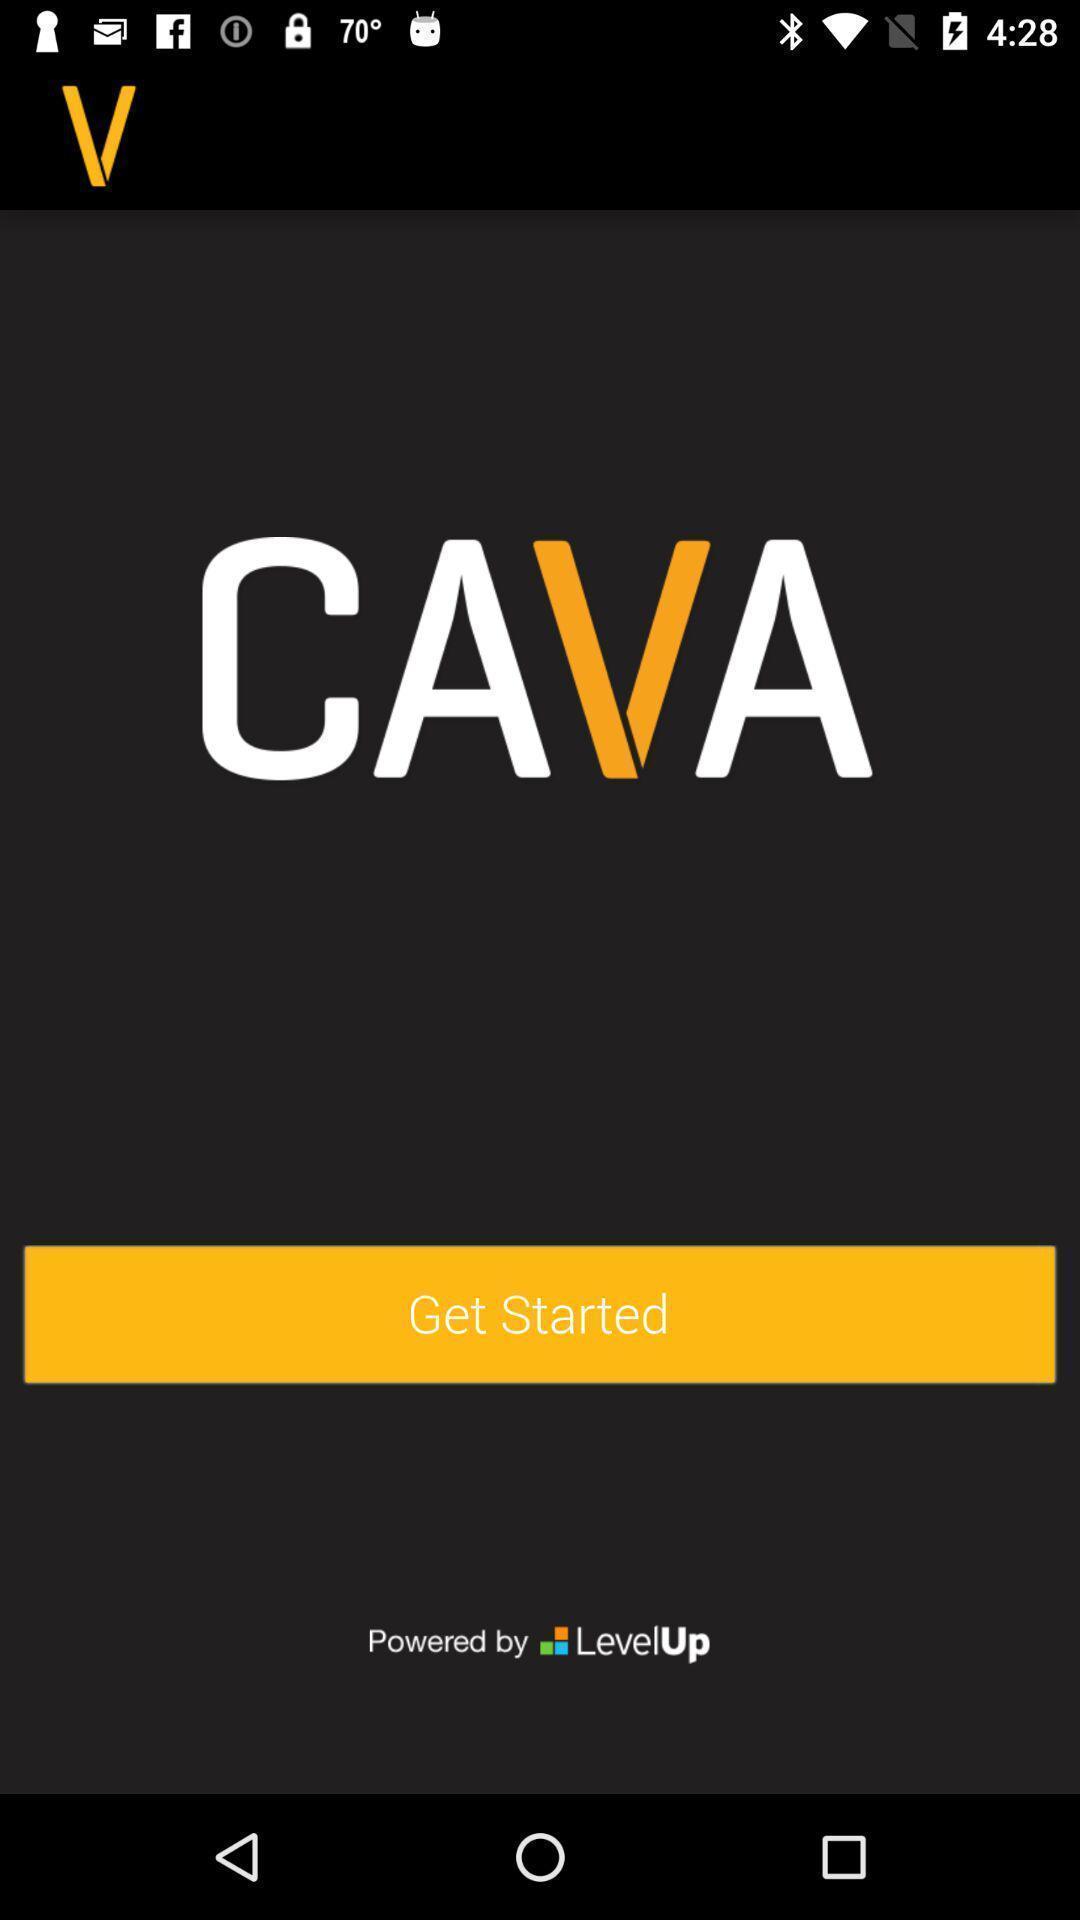Please provide a description for this image. Welcome page for an online food application. 